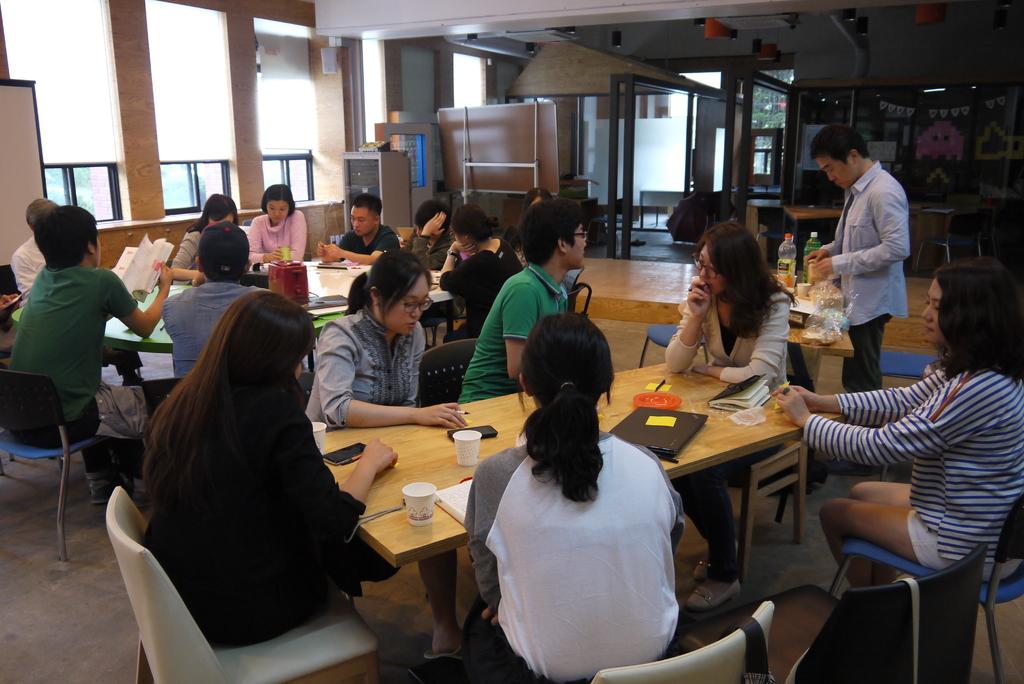What are the people in the image doing? People are sitting in groups around tables. Can you describe the position of the man in the image? There is a man standing at a table. What word is the man raking in the image? There is no man raking a word in the image; the man is standing at a table, and there is no mention of raking or words in the provided facts. 